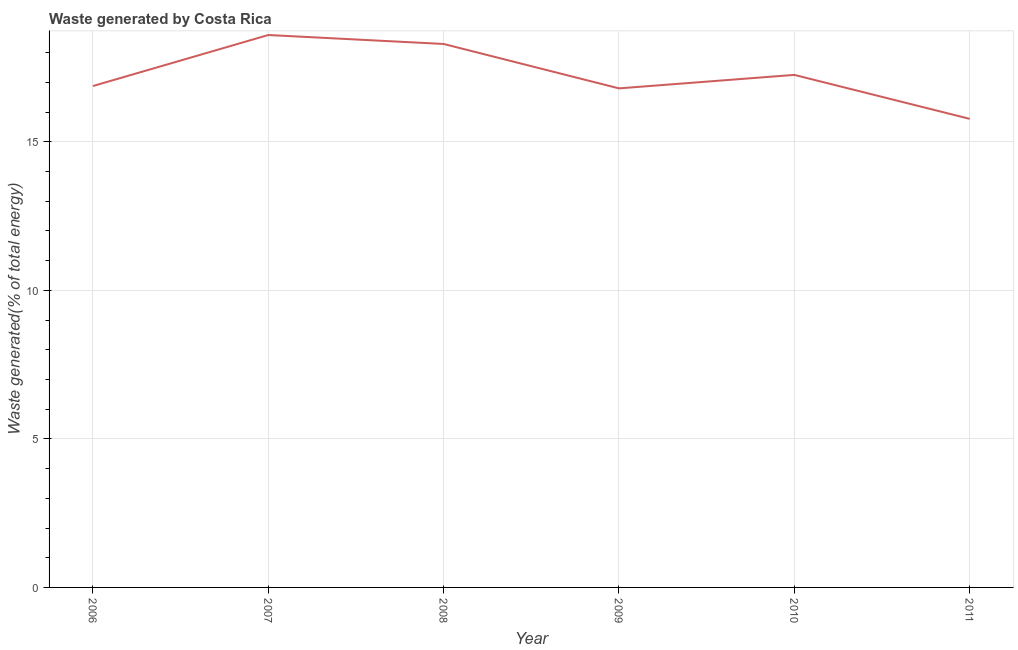What is the amount of waste generated in 2010?
Provide a succinct answer. 17.25. Across all years, what is the maximum amount of waste generated?
Offer a terse response. 18.59. Across all years, what is the minimum amount of waste generated?
Your answer should be very brief. 15.77. In which year was the amount of waste generated maximum?
Ensure brevity in your answer.  2007. What is the sum of the amount of waste generated?
Give a very brief answer. 103.58. What is the difference between the amount of waste generated in 2010 and 2011?
Your answer should be very brief. 1.48. What is the average amount of waste generated per year?
Provide a succinct answer. 17.26. What is the median amount of waste generated?
Your response must be concise. 17.06. What is the ratio of the amount of waste generated in 2007 to that in 2008?
Your answer should be compact. 1.02. What is the difference between the highest and the second highest amount of waste generated?
Offer a very short reply. 0.3. What is the difference between the highest and the lowest amount of waste generated?
Provide a succinct answer. 2.82. In how many years, is the amount of waste generated greater than the average amount of waste generated taken over all years?
Your answer should be very brief. 2. How many years are there in the graph?
Keep it short and to the point. 6. Does the graph contain grids?
Offer a very short reply. Yes. What is the title of the graph?
Provide a short and direct response. Waste generated by Costa Rica. What is the label or title of the X-axis?
Provide a succinct answer. Year. What is the label or title of the Y-axis?
Provide a succinct answer. Waste generated(% of total energy). What is the Waste generated(% of total energy) of 2006?
Provide a short and direct response. 16.88. What is the Waste generated(% of total energy) of 2007?
Keep it short and to the point. 18.59. What is the Waste generated(% of total energy) in 2008?
Provide a succinct answer. 18.29. What is the Waste generated(% of total energy) in 2009?
Ensure brevity in your answer.  16.8. What is the Waste generated(% of total energy) of 2010?
Provide a short and direct response. 17.25. What is the Waste generated(% of total energy) of 2011?
Offer a very short reply. 15.77. What is the difference between the Waste generated(% of total energy) in 2006 and 2007?
Offer a very short reply. -1.72. What is the difference between the Waste generated(% of total energy) in 2006 and 2008?
Offer a very short reply. -1.42. What is the difference between the Waste generated(% of total energy) in 2006 and 2009?
Offer a terse response. 0.08. What is the difference between the Waste generated(% of total energy) in 2006 and 2010?
Make the answer very short. -0.37. What is the difference between the Waste generated(% of total energy) in 2006 and 2011?
Keep it short and to the point. 1.1. What is the difference between the Waste generated(% of total energy) in 2007 and 2008?
Your response must be concise. 0.3. What is the difference between the Waste generated(% of total energy) in 2007 and 2009?
Keep it short and to the point. 1.8. What is the difference between the Waste generated(% of total energy) in 2007 and 2010?
Offer a very short reply. 1.34. What is the difference between the Waste generated(% of total energy) in 2007 and 2011?
Make the answer very short. 2.82. What is the difference between the Waste generated(% of total energy) in 2008 and 2009?
Offer a very short reply. 1.49. What is the difference between the Waste generated(% of total energy) in 2008 and 2010?
Your answer should be compact. 1.04. What is the difference between the Waste generated(% of total energy) in 2008 and 2011?
Offer a very short reply. 2.52. What is the difference between the Waste generated(% of total energy) in 2009 and 2010?
Provide a short and direct response. -0.45. What is the difference between the Waste generated(% of total energy) in 2009 and 2011?
Provide a succinct answer. 1.03. What is the difference between the Waste generated(% of total energy) in 2010 and 2011?
Ensure brevity in your answer.  1.48. What is the ratio of the Waste generated(% of total energy) in 2006 to that in 2007?
Your response must be concise. 0.91. What is the ratio of the Waste generated(% of total energy) in 2006 to that in 2008?
Offer a terse response. 0.92. What is the ratio of the Waste generated(% of total energy) in 2006 to that in 2009?
Give a very brief answer. 1. What is the ratio of the Waste generated(% of total energy) in 2006 to that in 2010?
Make the answer very short. 0.98. What is the ratio of the Waste generated(% of total energy) in 2006 to that in 2011?
Offer a terse response. 1.07. What is the ratio of the Waste generated(% of total energy) in 2007 to that in 2008?
Offer a terse response. 1.02. What is the ratio of the Waste generated(% of total energy) in 2007 to that in 2009?
Keep it short and to the point. 1.11. What is the ratio of the Waste generated(% of total energy) in 2007 to that in 2010?
Keep it short and to the point. 1.08. What is the ratio of the Waste generated(% of total energy) in 2007 to that in 2011?
Provide a short and direct response. 1.18. What is the ratio of the Waste generated(% of total energy) in 2008 to that in 2009?
Provide a short and direct response. 1.09. What is the ratio of the Waste generated(% of total energy) in 2008 to that in 2010?
Offer a very short reply. 1.06. What is the ratio of the Waste generated(% of total energy) in 2008 to that in 2011?
Ensure brevity in your answer.  1.16. What is the ratio of the Waste generated(% of total energy) in 2009 to that in 2011?
Keep it short and to the point. 1.06. What is the ratio of the Waste generated(% of total energy) in 2010 to that in 2011?
Offer a very short reply. 1.09. 